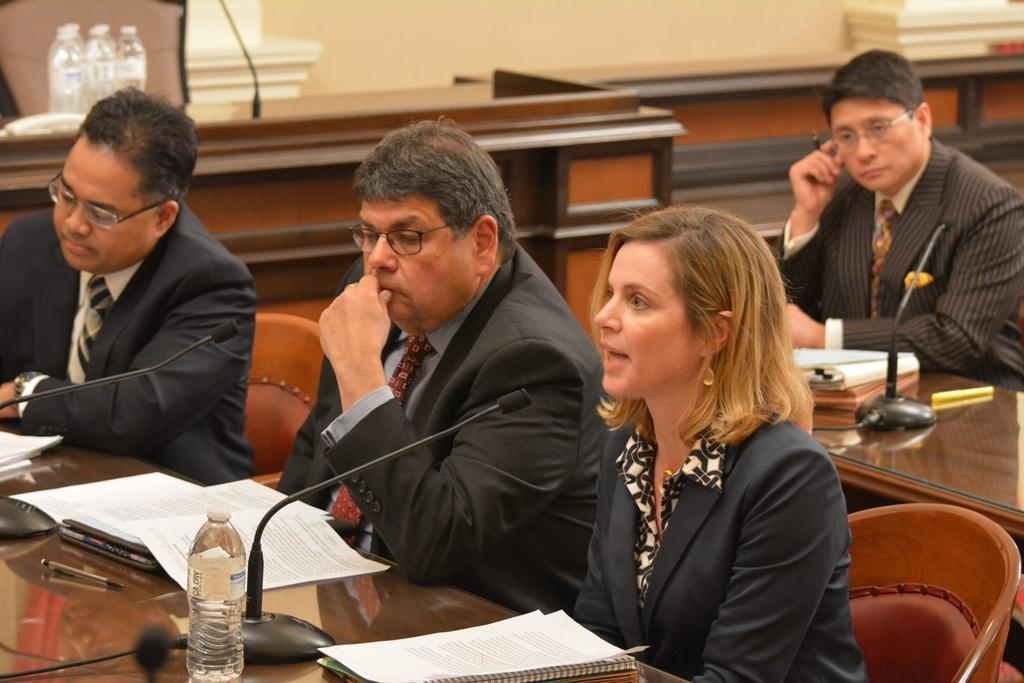Who is present in the image? There are people in the image. What are the people doing in the image? The people are sitting on chairs and engaged in a discussion. What type of pies are being served during the discussion in the image? There is no mention of pies or any food being served in the image; the people are simply engaged in a discussion. 